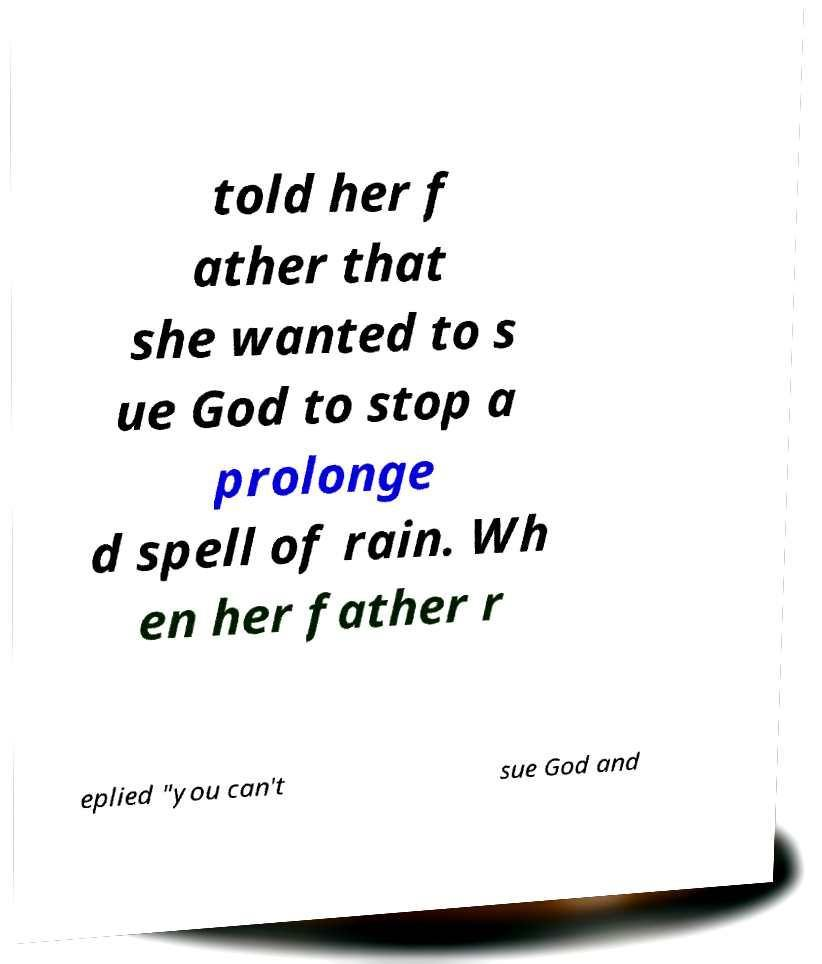Please identify and transcribe the text found in this image. told her f ather that she wanted to s ue God to stop a prolonge d spell of rain. Wh en her father r eplied "you can't sue God and 